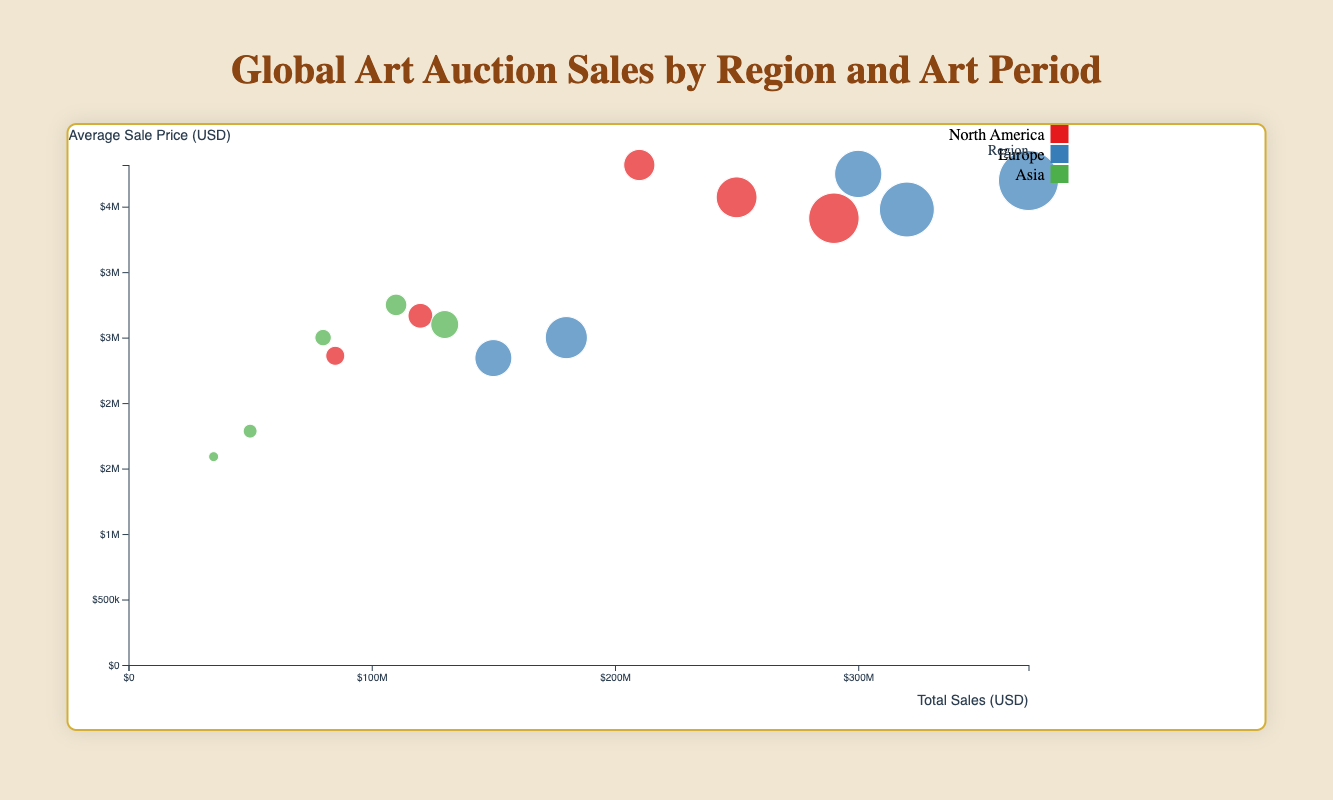What are the axes labeled as? The x-axis is labeled "Total Sales (USD)" and the y-axis is labeled "Average Sale Price (USD)", indicating that the chart shows total art sales on the horizontal axis and average sale price on the vertical axis.
Answer: Total Sales (USD) and Average Sale Price (USD) Which region has the highest total sales for Contemporary Art? To find this, look for the bubbles in the Contemporary Art period with the highest x-coordinate (total sales). The Europe region has a bubble situated farthest to the right.
Answer: Europe How many regions are represented in the chart, and which colors are used to distinguish them? Identifying the legend of the chart shows regions and associated colors. The regions are North America, Europe, and Asia, represented by red, blue, and green colors, respectively.
Answer: 3; red, blue, green What is the total sales amount for the North America region across all art periods? Adding total sales from the specific art periods for North America, the values are 120M + 85M + 210M + 250M + 290M USD. Summing these gives: 955M USD.
Answer: 955 million USD Which art period has the highest average sale price for North America? By comparing the average sale prices of North America across all art periods, Impressionism, with an average sale price of $3,818,182, comes out highest.
Answer: Impressionism Compare the total sales in Asia for Baroque and Modern Art. Which one is higher and by how much? The total sales for Baroque in Asia is $35M and for Modern Art is $110M. Subtracting $35M from $110M gives a difference of $75M. Modern Art has higher sales by $75M.
Answer: Modern Art; $75 million Which region has the largest bubble (indicative of the number of auctions) for the Impressionism art period? Observing the size of the bubbles for the Impressionism period, Europe has the largest bubble, indicating it has the highest number of auctions.
Answer: Europe What is the relationship between total sales and average sale price for Renaissance paintings in Europe? By locating the bubble for Renaissance in Europe, note that total sales is $180M and the average sale price is $2.5M. Higher total sales with moderate average price suggests a higher number of auctions.
Answer: Higher total sales and moderate average price What are the minimum and maximum number of auctions held across all regions and art periods? From the data, the minimum number is 22 for Baroque art in Asia and the maximum number is 100 for Contemporary Art in Europe.
Answer: 22 and 100 Which art period has the smallest average sale price in Asia? By comparing the average sale prices of Asia across all art periods, Baroque has the smallest with an average sale price of $1,590,909.
Answer: Baroque 